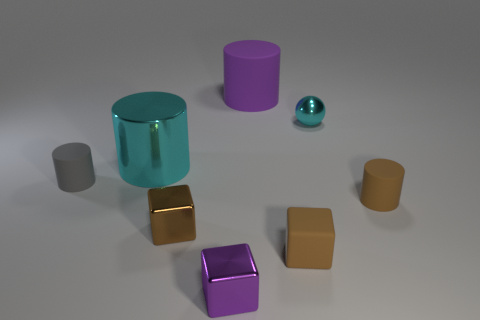Which object stands out the most in this image and why? The shiny, reflective cyan cylinder stands out the most due to its vibrant color and glossy surface, which contrasts with the more subdued colors and matte textures of the other objects. 